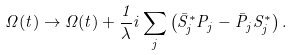Convert formula to latex. <formula><loc_0><loc_0><loc_500><loc_500>\Omega ( t ) \rightarrow \Omega ( t ) + \frac { 1 } { \lambda } i \sum _ { j } \left ( \bar { S } _ { j } ^ { * } P _ { j } - \bar { P } _ { j } S _ { j } ^ { * } \right ) .</formula> 